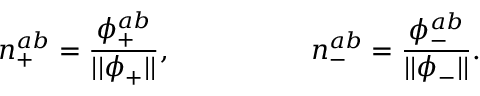<formula> <loc_0><loc_0><loc_500><loc_500>n _ { + } ^ { a b } = \frac { \phi _ { + } ^ { a b } } { | | \phi _ { + } | | } , \quad n _ { - } ^ { a b } = \frac { \phi _ { - } ^ { a b } } { | | \phi _ { - } | | } .</formula> 